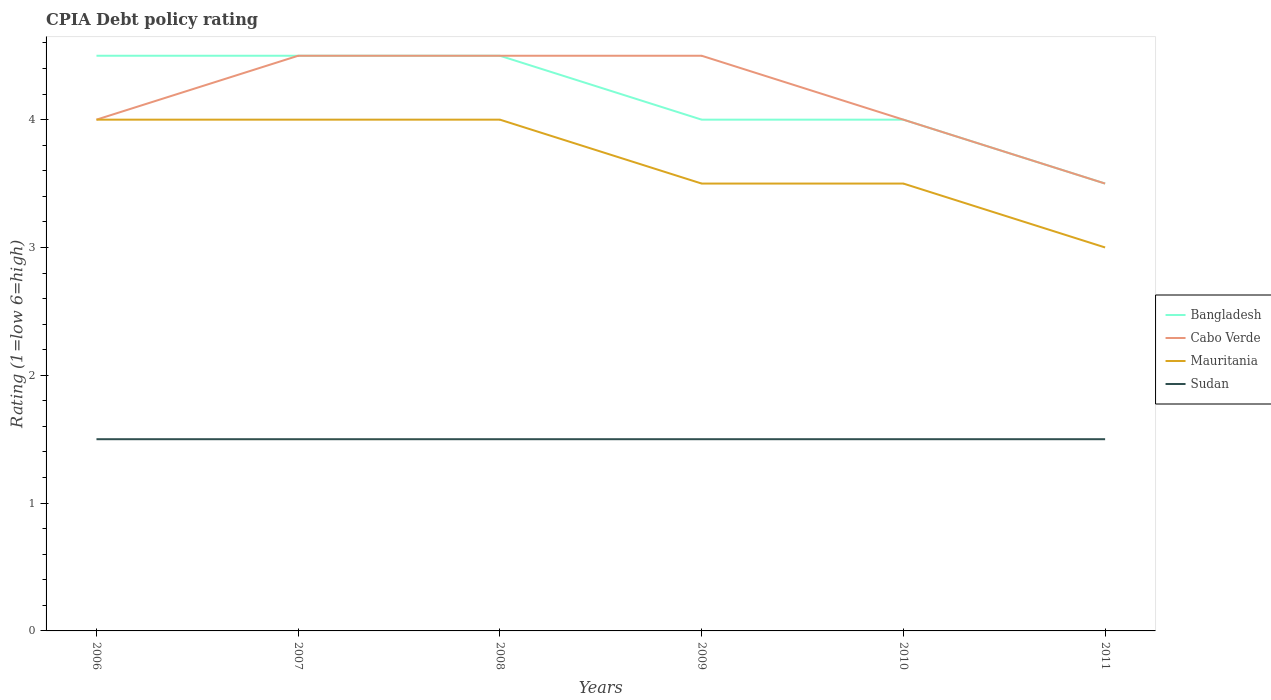Does the line corresponding to Cabo Verde intersect with the line corresponding to Bangladesh?
Your answer should be very brief. Yes. Across all years, what is the maximum CPIA rating in Sudan?
Provide a succinct answer. 1.5. What is the total CPIA rating in Bangladesh in the graph?
Your answer should be compact. 1. What is the difference between the highest and the lowest CPIA rating in Bangladesh?
Your response must be concise. 3. Is the CPIA rating in Bangladesh strictly greater than the CPIA rating in Sudan over the years?
Offer a terse response. No. What is the difference between two consecutive major ticks on the Y-axis?
Make the answer very short. 1. Are the values on the major ticks of Y-axis written in scientific E-notation?
Make the answer very short. No. Does the graph contain any zero values?
Ensure brevity in your answer.  No. Does the graph contain grids?
Offer a very short reply. No. What is the title of the graph?
Give a very brief answer. CPIA Debt policy rating. Does "Grenada" appear as one of the legend labels in the graph?
Make the answer very short. No. What is the label or title of the X-axis?
Provide a succinct answer. Years. What is the label or title of the Y-axis?
Make the answer very short. Rating (1=low 6=high). What is the Rating (1=low 6=high) in Mauritania in 2006?
Provide a succinct answer. 4. What is the Rating (1=low 6=high) of Sudan in 2006?
Make the answer very short. 1.5. What is the Rating (1=low 6=high) of Mauritania in 2007?
Offer a very short reply. 4. What is the Rating (1=low 6=high) in Mauritania in 2008?
Your response must be concise. 4. What is the Rating (1=low 6=high) of Cabo Verde in 2009?
Provide a succinct answer. 4.5. What is the Rating (1=low 6=high) of Bangladesh in 2011?
Make the answer very short. 3.5. What is the Rating (1=low 6=high) of Cabo Verde in 2011?
Your response must be concise. 3.5. What is the Rating (1=low 6=high) in Mauritania in 2011?
Provide a succinct answer. 3. What is the Rating (1=low 6=high) of Sudan in 2011?
Keep it short and to the point. 1.5. Across all years, what is the maximum Rating (1=low 6=high) in Bangladesh?
Offer a very short reply. 4.5. Across all years, what is the maximum Rating (1=low 6=high) in Cabo Verde?
Provide a short and direct response. 4.5. Across all years, what is the maximum Rating (1=low 6=high) of Mauritania?
Offer a very short reply. 4. What is the total Rating (1=low 6=high) of Bangladesh in the graph?
Keep it short and to the point. 25. What is the total Rating (1=low 6=high) in Mauritania in the graph?
Your answer should be compact. 22. What is the total Rating (1=low 6=high) of Sudan in the graph?
Give a very brief answer. 9. What is the difference between the Rating (1=low 6=high) in Bangladesh in 2006 and that in 2007?
Your response must be concise. 0. What is the difference between the Rating (1=low 6=high) of Sudan in 2006 and that in 2007?
Provide a short and direct response. 0. What is the difference between the Rating (1=low 6=high) in Bangladesh in 2006 and that in 2008?
Your response must be concise. 0. What is the difference between the Rating (1=low 6=high) of Sudan in 2006 and that in 2008?
Give a very brief answer. 0. What is the difference between the Rating (1=low 6=high) of Bangladesh in 2006 and that in 2009?
Offer a terse response. 0.5. What is the difference between the Rating (1=low 6=high) in Cabo Verde in 2006 and that in 2009?
Your answer should be compact. -0.5. What is the difference between the Rating (1=low 6=high) of Mauritania in 2006 and that in 2009?
Ensure brevity in your answer.  0.5. What is the difference between the Rating (1=low 6=high) of Bangladesh in 2006 and that in 2010?
Give a very brief answer. 0.5. What is the difference between the Rating (1=low 6=high) of Bangladesh in 2006 and that in 2011?
Offer a terse response. 1. What is the difference between the Rating (1=low 6=high) of Mauritania in 2006 and that in 2011?
Keep it short and to the point. 1. What is the difference between the Rating (1=low 6=high) in Sudan in 2006 and that in 2011?
Make the answer very short. 0. What is the difference between the Rating (1=low 6=high) of Cabo Verde in 2007 and that in 2009?
Provide a short and direct response. 0. What is the difference between the Rating (1=low 6=high) of Sudan in 2007 and that in 2009?
Ensure brevity in your answer.  0. What is the difference between the Rating (1=low 6=high) of Cabo Verde in 2007 and that in 2010?
Your answer should be very brief. 0.5. What is the difference between the Rating (1=low 6=high) in Mauritania in 2007 and that in 2011?
Give a very brief answer. 1. What is the difference between the Rating (1=low 6=high) in Sudan in 2007 and that in 2011?
Offer a terse response. 0. What is the difference between the Rating (1=low 6=high) in Mauritania in 2008 and that in 2009?
Your answer should be compact. 0.5. What is the difference between the Rating (1=low 6=high) of Sudan in 2008 and that in 2009?
Provide a short and direct response. 0. What is the difference between the Rating (1=low 6=high) in Bangladesh in 2008 and that in 2010?
Provide a short and direct response. 0.5. What is the difference between the Rating (1=low 6=high) of Mauritania in 2008 and that in 2010?
Keep it short and to the point. 0.5. What is the difference between the Rating (1=low 6=high) in Bangladesh in 2008 and that in 2011?
Provide a succinct answer. 1. What is the difference between the Rating (1=low 6=high) of Cabo Verde in 2008 and that in 2011?
Your answer should be very brief. 1. What is the difference between the Rating (1=low 6=high) in Mauritania in 2008 and that in 2011?
Offer a terse response. 1. What is the difference between the Rating (1=low 6=high) of Sudan in 2008 and that in 2011?
Offer a very short reply. 0. What is the difference between the Rating (1=low 6=high) of Bangladesh in 2009 and that in 2010?
Your answer should be very brief. 0. What is the difference between the Rating (1=low 6=high) in Mauritania in 2009 and that in 2010?
Keep it short and to the point. 0. What is the difference between the Rating (1=low 6=high) in Cabo Verde in 2009 and that in 2011?
Provide a short and direct response. 1. What is the difference between the Rating (1=low 6=high) of Mauritania in 2009 and that in 2011?
Offer a very short reply. 0.5. What is the difference between the Rating (1=low 6=high) in Sudan in 2009 and that in 2011?
Provide a short and direct response. 0. What is the difference between the Rating (1=low 6=high) of Cabo Verde in 2010 and that in 2011?
Give a very brief answer. 0.5. What is the difference between the Rating (1=low 6=high) of Sudan in 2010 and that in 2011?
Your response must be concise. 0. What is the difference between the Rating (1=low 6=high) of Bangladesh in 2006 and the Rating (1=low 6=high) of Cabo Verde in 2007?
Make the answer very short. 0. What is the difference between the Rating (1=low 6=high) of Bangladesh in 2006 and the Rating (1=low 6=high) of Sudan in 2007?
Make the answer very short. 3. What is the difference between the Rating (1=low 6=high) in Cabo Verde in 2006 and the Rating (1=low 6=high) in Sudan in 2007?
Keep it short and to the point. 2.5. What is the difference between the Rating (1=low 6=high) in Bangladesh in 2006 and the Rating (1=low 6=high) in Cabo Verde in 2008?
Make the answer very short. 0. What is the difference between the Rating (1=low 6=high) of Cabo Verde in 2006 and the Rating (1=low 6=high) of Mauritania in 2008?
Give a very brief answer. 0. What is the difference between the Rating (1=low 6=high) of Bangladesh in 2006 and the Rating (1=low 6=high) of Mauritania in 2009?
Offer a very short reply. 1. What is the difference between the Rating (1=low 6=high) of Bangladesh in 2006 and the Rating (1=low 6=high) of Sudan in 2009?
Provide a short and direct response. 3. What is the difference between the Rating (1=low 6=high) of Bangladesh in 2006 and the Rating (1=low 6=high) of Cabo Verde in 2010?
Offer a terse response. 0.5. What is the difference between the Rating (1=low 6=high) of Bangladesh in 2006 and the Rating (1=low 6=high) of Sudan in 2010?
Make the answer very short. 3. What is the difference between the Rating (1=low 6=high) of Cabo Verde in 2006 and the Rating (1=low 6=high) of Sudan in 2010?
Keep it short and to the point. 2.5. What is the difference between the Rating (1=low 6=high) of Mauritania in 2006 and the Rating (1=low 6=high) of Sudan in 2010?
Provide a short and direct response. 2.5. What is the difference between the Rating (1=low 6=high) in Bangladesh in 2006 and the Rating (1=low 6=high) in Cabo Verde in 2011?
Provide a succinct answer. 1. What is the difference between the Rating (1=low 6=high) in Bangladesh in 2006 and the Rating (1=low 6=high) in Sudan in 2011?
Your answer should be compact. 3. What is the difference between the Rating (1=low 6=high) of Mauritania in 2006 and the Rating (1=low 6=high) of Sudan in 2011?
Offer a terse response. 2.5. What is the difference between the Rating (1=low 6=high) in Bangladesh in 2007 and the Rating (1=low 6=high) in Cabo Verde in 2008?
Your answer should be compact. 0. What is the difference between the Rating (1=low 6=high) in Bangladesh in 2007 and the Rating (1=low 6=high) in Mauritania in 2008?
Your response must be concise. 0.5. What is the difference between the Rating (1=low 6=high) in Bangladesh in 2007 and the Rating (1=low 6=high) in Sudan in 2008?
Offer a terse response. 3. What is the difference between the Rating (1=low 6=high) in Cabo Verde in 2007 and the Rating (1=low 6=high) in Sudan in 2008?
Your answer should be compact. 3. What is the difference between the Rating (1=low 6=high) in Bangladesh in 2007 and the Rating (1=low 6=high) in Cabo Verde in 2009?
Provide a succinct answer. 0. What is the difference between the Rating (1=low 6=high) of Bangladesh in 2007 and the Rating (1=low 6=high) of Mauritania in 2009?
Offer a terse response. 1. What is the difference between the Rating (1=low 6=high) in Cabo Verde in 2007 and the Rating (1=low 6=high) in Sudan in 2009?
Your response must be concise. 3. What is the difference between the Rating (1=low 6=high) in Mauritania in 2007 and the Rating (1=low 6=high) in Sudan in 2009?
Make the answer very short. 2.5. What is the difference between the Rating (1=low 6=high) in Bangladesh in 2007 and the Rating (1=low 6=high) in Cabo Verde in 2010?
Offer a very short reply. 0.5. What is the difference between the Rating (1=low 6=high) in Bangladesh in 2007 and the Rating (1=low 6=high) in Mauritania in 2010?
Provide a short and direct response. 1. What is the difference between the Rating (1=low 6=high) in Mauritania in 2007 and the Rating (1=low 6=high) in Sudan in 2010?
Make the answer very short. 2.5. What is the difference between the Rating (1=low 6=high) of Cabo Verde in 2007 and the Rating (1=low 6=high) of Mauritania in 2011?
Your response must be concise. 1.5. What is the difference between the Rating (1=low 6=high) of Cabo Verde in 2007 and the Rating (1=low 6=high) of Sudan in 2011?
Provide a succinct answer. 3. What is the difference between the Rating (1=low 6=high) of Mauritania in 2007 and the Rating (1=low 6=high) of Sudan in 2011?
Offer a terse response. 2.5. What is the difference between the Rating (1=low 6=high) of Bangladesh in 2008 and the Rating (1=low 6=high) of Cabo Verde in 2009?
Keep it short and to the point. 0. What is the difference between the Rating (1=low 6=high) in Bangladesh in 2008 and the Rating (1=low 6=high) in Mauritania in 2009?
Provide a short and direct response. 1. What is the difference between the Rating (1=low 6=high) of Bangladesh in 2008 and the Rating (1=low 6=high) of Sudan in 2009?
Provide a short and direct response. 3. What is the difference between the Rating (1=low 6=high) of Cabo Verde in 2008 and the Rating (1=low 6=high) of Mauritania in 2009?
Keep it short and to the point. 1. What is the difference between the Rating (1=low 6=high) of Cabo Verde in 2008 and the Rating (1=low 6=high) of Sudan in 2009?
Your response must be concise. 3. What is the difference between the Rating (1=low 6=high) of Bangladesh in 2008 and the Rating (1=low 6=high) of Cabo Verde in 2010?
Your answer should be compact. 0.5. What is the difference between the Rating (1=low 6=high) in Bangladesh in 2008 and the Rating (1=low 6=high) in Mauritania in 2011?
Your response must be concise. 1.5. What is the difference between the Rating (1=low 6=high) of Bangladesh in 2008 and the Rating (1=low 6=high) of Sudan in 2011?
Offer a terse response. 3. What is the difference between the Rating (1=low 6=high) of Mauritania in 2008 and the Rating (1=low 6=high) of Sudan in 2011?
Offer a very short reply. 2.5. What is the difference between the Rating (1=low 6=high) in Bangladesh in 2009 and the Rating (1=low 6=high) in Cabo Verde in 2010?
Your response must be concise. 0. What is the difference between the Rating (1=low 6=high) of Bangladesh in 2009 and the Rating (1=low 6=high) of Cabo Verde in 2011?
Make the answer very short. 0.5. What is the difference between the Rating (1=low 6=high) in Cabo Verde in 2009 and the Rating (1=low 6=high) in Sudan in 2011?
Your answer should be compact. 3. What is the difference between the Rating (1=low 6=high) in Bangladesh in 2010 and the Rating (1=low 6=high) in Mauritania in 2011?
Provide a succinct answer. 1. What is the difference between the Rating (1=low 6=high) in Bangladesh in 2010 and the Rating (1=low 6=high) in Sudan in 2011?
Offer a terse response. 2.5. What is the difference between the Rating (1=low 6=high) in Cabo Verde in 2010 and the Rating (1=low 6=high) in Mauritania in 2011?
Keep it short and to the point. 1. What is the difference between the Rating (1=low 6=high) of Cabo Verde in 2010 and the Rating (1=low 6=high) of Sudan in 2011?
Your response must be concise. 2.5. What is the average Rating (1=low 6=high) of Bangladesh per year?
Ensure brevity in your answer.  4.17. What is the average Rating (1=low 6=high) in Cabo Verde per year?
Your answer should be compact. 4.17. What is the average Rating (1=low 6=high) of Mauritania per year?
Give a very brief answer. 3.67. What is the average Rating (1=low 6=high) of Sudan per year?
Your answer should be compact. 1.5. In the year 2006, what is the difference between the Rating (1=low 6=high) of Cabo Verde and Rating (1=low 6=high) of Mauritania?
Your answer should be very brief. 0. In the year 2006, what is the difference between the Rating (1=low 6=high) in Cabo Verde and Rating (1=low 6=high) in Sudan?
Make the answer very short. 2.5. In the year 2006, what is the difference between the Rating (1=low 6=high) of Mauritania and Rating (1=low 6=high) of Sudan?
Keep it short and to the point. 2.5. In the year 2007, what is the difference between the Rating (1=low 6=high) in Cabo Verde and Rating (1=low 6=high) in Mauritania?
Make the answer very short. 0.5. In the year 2007, what is the difference between the Rating (1=low 6=high) in Mauritania and Rating (1=low 6=high) in Sudan?
Ensure brevity in your answer.  2.5. In the year 2008, what is the difference between the Rating (1=low 6=high) in Bangladesh and Rating (1=low 6=high) in Cabo Verde?
Make the answer very short. 0. In the year 2008, what is the difference between the Rating (1=low 6=high) of Bangladesh and Rating (1=low 6=high) of Mauritania?
Offer a terse response. 0.5. In the year 2008, what is the difference between the Rating (1=low 6=high) of Bangladesh and Rating (1=low 6=high) of Sudan?
Offer a very short reply. 3. In the year 2009, what is the difference between the Rating (1=low 6=high) in Bangladesh and Rating (1=low 6=high) in Cabo Verde?
Your response must be concise. -0.5. In the year 2009, what is the difference between the Rating (1=low 6=high) of Bangladesh and Rating (1=low 6=high) of Sudan?
Your answer should be compact. 2.5. In the year 2009, what is the difference between the Rating (1=low 6=high) of Cabo Verde and Rating (1=low 6=high) of Mauritania?
Offer a terse response. 1. In the year 2009, what is the difference between the Rating (1=low 6=high) of Cabo Verde and Rating (1=low 6=high) of Sudan?
Offer a terse response. 3. In the year 2009, what is the difference between the Rating (1=low 6=high) in Mauritania and Rating (1=low 6=high) in Sudan?
Provide a short and direct response. 2. In the year 2010, what is the difference between the Rating (1=low 6=high) in Bangladesh and Rating (1=low 6=high) in Mauritania?
Give a very brief answer. 0.5. In the year 2010, what is the difference between the Rating (1=low 6=high) of Cabo Verde and Rating (1=low 6=high) of Mauritania?
Offer a very short reply. 0.5. In the year 2011, what is the difference between the Rating (1=low 6=high) of Bangladesh and Rating (1=low 6=high) of Cabo Verde?
Offer a very short reply. 0. In the year 2011, what is the difference between the Rating (1=low 6=high) in Bangladesh and Rating (1=low 6=high) in Mauritania?
Provide a short and direct response. 0.5. In the year 2011, what is the difference between the Rating (1=low 6=high) of Bangladesh and Rating (1=low 6=high) of Sudan?
Your answer should be very brief. 2. In the year 2011, what is the difference between the Rating (1=low 6=high) of Mauritania and Rating (1=low 6=high) of Sudan?
Your answer should be very brief. 1.5. What is the ratio of the Rating (1=low 6=high) of Bangladesh in 2006 to that in 2007?
Provide a succinct answer. 1. What is the ratio of the Rating (1=low 6=high) in Sudan in 2006 to that in 2008?
Provide a short and direct response. 1. What is the ratio of the Rating (1=low 6=high) in Sudan in 2006 to that in 2009?
Your response must be concise. 1. What is the ratio of the Rating (1=low 6=high) in Bangladesh in 2006 to that in 2010?
Offer a very short reply. 1.12. What is the ratio of the Rating (1=low 6=high) in Cabo Verde in 2006 to that in 2010?
Your answer should be very brief. 1. What is the ratio of the Rating (1=low 6=high) in Mauritania in 2006 to that in 2010?
Keep it short and to the point. 1.14. What is the ratio of the Rating (1=low 6=high) in Bangladesh in 2006 to that in 2011?
Your answer should be very brief. 1.29. What is the ratio of the Rating (1=low 6=high) of Mauritania in 2006 to that in 2011?
Make the answer very short. 1.33. What is the ratio of the Rating (1=low 6=high) in Sudan in 2006 to that in 2011?
Offer a very short reply. 1. What is the ratio of the Rating (1=low 6=high) of Bangladesh in 2007 to that in 2008?
Keep it short and to the point. 1. What is the ratio of the Rating (1=low 6=high) in Bangladesh in 2007 to that in 2009?
Give a very brief answer. 1.12. What is the ratio of the Rating (1=low 6=high) in Sudan in 2007 to that in 2009?
Give a very brief answer. 1. What is the ratio of the Rating (1=low 6=high) of Bangladesh in 2007 to that in 2010?
Give a very brief answer. 1.12. What is the ratio of the Rating (1=low 6=high) in Sudan in 2007 to that in 2010?
Your answer should be compact. 1. What is the ratio of the Rating (1=low 6=high) of Bangladesh in 2007 to that in 2011?
Give a very brief answer. 1.29. What is the ratio of the Rating (1=low 6=high) in Cabo Verde in 2008 to that in 2009?
Give a very brief answer. 1. What is the ratio of the Rating (1=low 6=high) in Sudan in 2008 to that in 2009?
Your answer should be very brief. 1. What is the ratio of the Rating (1=low 6=high) of Bangladesh in 2008 to that in 2010?
Provide a short and direct response. 1.12. What is the ratio of the Rating (1=low 6=high) in Cabo Verde in 2008 to that in 2010?
Give a very brief answer. 1.12. What is the ratio of the Rating (1=low 6=high) in Sudan in 2008 to that in 2010?
Offer a terse response. 1. What is the ratio of the Rating (1=low 6=high) of Bangladesh in 2008 to that in 2011?
Your response must be concise. 1.29. What is the ratio of the Rating (1=low 6=high) in Mauritania in 2008 to that in 2011?
Your response must be concise. 1.33. What is the ratio of the Rating (1=low 6=high) in Bangladesh in 2009 to that in 2010?
Keep it short and to the point. 1. What is the ratio of the Rating (1=low 6=high) in Mauritania in 2009 to that in 2010?
Provide a short and direct response. 1. What is the ratio of the Rating (1=low 6=high) of Sudan in 2009 to that in 2010?
Your answer should be compact. 1. What is the ratio of the Rating (1=low 6=high) in Cabo Verde in 2009 to that in 2011?
Your answer should be very brief. 1.29. What is the ratio of the Rating (1=low 6=high) in Mauritania in 2010 to that in 2011?
Your response must be concise. 1.17. What is the difference between the highest and the second highest Rating (1=low 6=high) in Cabo Verde?
Offer a very short reply. 0. What is the difference between the highest and the second highest Rating (1=low 6=high) of Mauritania?
Offer a terse response. 0. What is the difference between the highest and the second highest Rating (1=low 6=high) in Sudan?
Give a very brief answer. 0. What is the difference between the highest and the lowest Rating (1=low 6=high) of Mauritania?
Your answer should be very brief. 1. What is the difference between the highest and the lowest Rating (1=low 6=high) in Sudan?
Your answer should be compact. 0. 